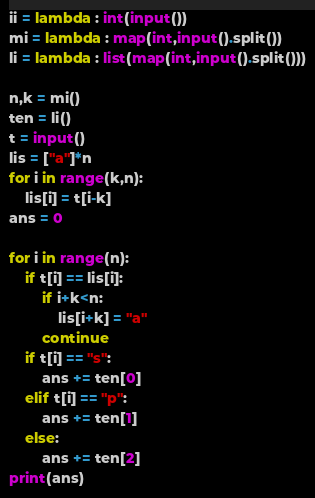<code> <loc_0><loc_0><loc_500><loc_500><_Python_>ii = lambda : int(input())
mi = lambda : map(int,input().split())
li = lambda : list(map(int,input().split()))

n,k = mi()
ten = li()
t = input()
lis = ["a"]*n
for i in range(k,n):
    lis[i] = t[i-k]
ans = 0

for i in range(n):
    if t[i] == lis[i]:
        if i+k<n:
            lis[i+k] = "a"
        continue
    if t[i] == "s":
        ans += ten[0]
    elif t[i] == "p":
        ans += ten[1]
    else:
        ans += ten[2]
print(ans)
</code> 